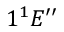Convert formula to latex. <formula><loc_0><loc_0><loc_500><loc_500>1 ^ { 1 } E ^ { \prime \prime }</formula> 